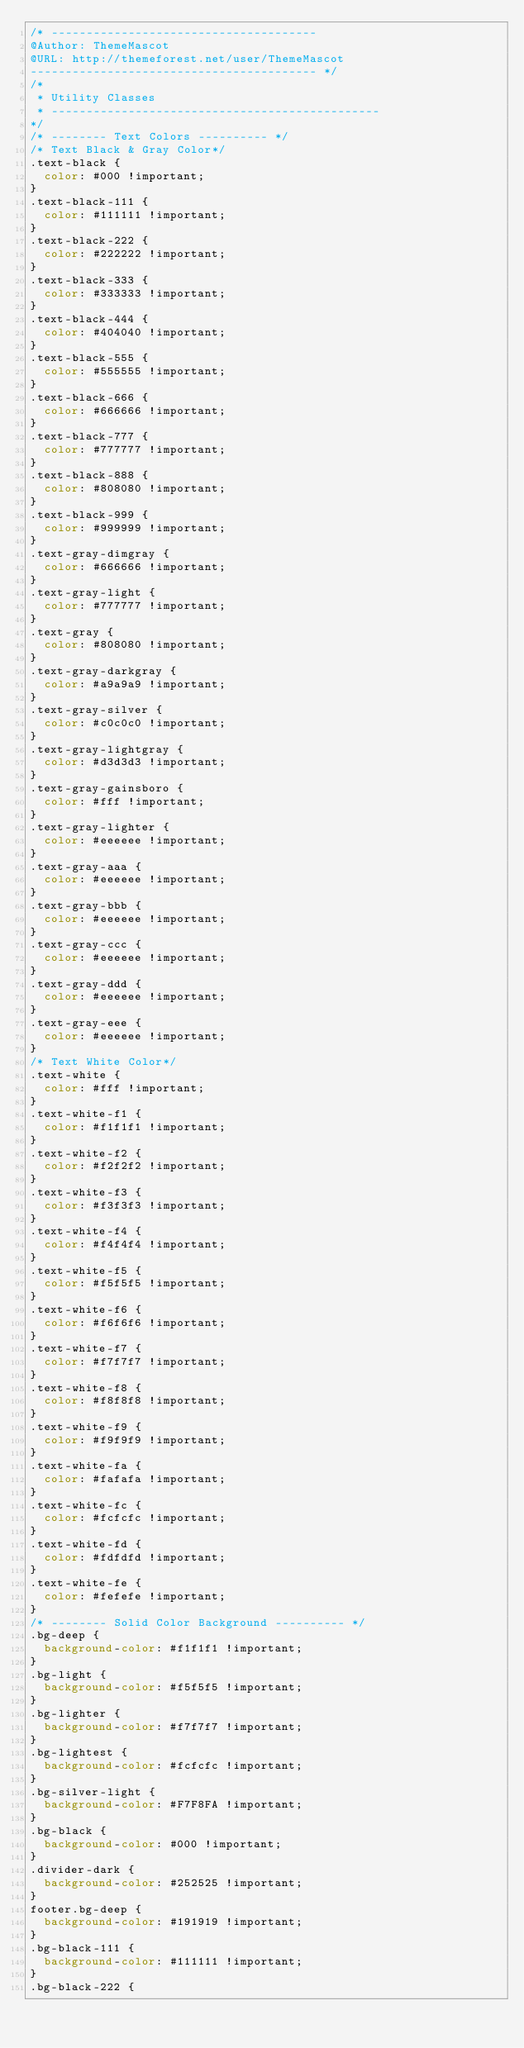<code> <loc_0><loc_0><loc_500><loc_500><_CSS_>/* --------------------------------------
@Author: ThemeMascot
@URL: http://themeforest.net/user/ThemeMascot
----------------------------------------- */
/*
 * Utility Classes
 * -----------------------------------------------
*/
/* -------- Text Colors ---------- */
/* Text Black & Gray Color*/
.text-black {
  color: #000 !important;
}
.text-black-111 {
  color: #111111 !important;
}
.text-black-222 {
  color: #222222 !important;
}
.text-black-333 {
  color: #333333 !important;
}
.text-black-444 {
  color: #404040 !important;
}
.text-black-555 {
  color: #555555 !important;
}
.text-black-666 {
  color: #666666 !important;
}
.text-black-777 {
  color: #777777 !important;
}
.text-black-888 {
  color: #808080 !important;
}
.text-black-999 {
  color: #999999 !important;
}
.text-gray-dimgray {
  color: #666666 !important;
}
.text-gray-light {
  color: #777777 !important;
}
.text-gray {
  color: #808080 !important;
}
.text-gray-darkgray {
  color: #a9a9a9 !important;
}
.text-gray-silver {
  color: #c0c0c0 !important;
}
.text-gray-lightgray {
  color: #d3d3d3 !important;
}
.text-gray-gainsboro {
  color: #fff !important;
}
.text-gray-lighter {
  color: #eeeeee !important;
}
.text-gray-aaa {
  color: #eeeeee !important;
}
.text-gray-bbb {
  color: #eeeeee !important;
}
.text-gray-ccc {
  color: #eeeeee !important;
}
.text-gray-ddd {
  color: #eeeeee !important;
}
.text-gray-eee {
  color: #eeeeee !important;
}
/* Text White Color*/
.text-white {
  color: #fff !important;
}
.text-white-f1 {
  color: #f1f1f1 !important;
}
.text-white-f2 {
  color: #f2f2f2 !important;
}
.text-white-f3 {
  color: #f3f3f3 !important;
}
.text-white-f4 {
  color: #f4f4f4 !important;
}
.text-white-f5 {
  color: #f5f5f5 !important;
}
.text-white-f6 {
  color: #f6f6f6 !important;
}
.text-white-f7 {
  color: #f7f7f7 !important;
}
.text-white-f8 {
  color: #f8f8f8 !important;
}
.text-white-f9 {
  color: #f9f9f9 !important;
}
.text-white-fa {
  color: #fafafa !important;
}
.text-white-fc {
  color: #fcfcfc !important;
}
.text-white-fd {
  color: #fdfdfd !important;
}
.text-white-fe {
  color: #fefefe !important;
}
/* -------- Solid Color Background ---------- */
.bg-deep {
  background-color: #f1f1f1 !important;
}
.bg-light {
  background-color: #f5f5f5 !important;
}
.bg-lighter {
  background-color: #f7f7f7 !important;
}
.bg-lightest {
  background-color: #fcfcfc !important;
}
.bg-silver-light {
  background-color: #F7F8FA !important;
}
.bg-black {
  background-color: #000 !important;
}
.divider-dark {
  background-color: #252525 !important;
}
footer.bg-deep {
  background-color: #191919 !important;
}
.bg-black-111 {
  background-color: #111111 !important;
}
.bg-black-222 {</code> 